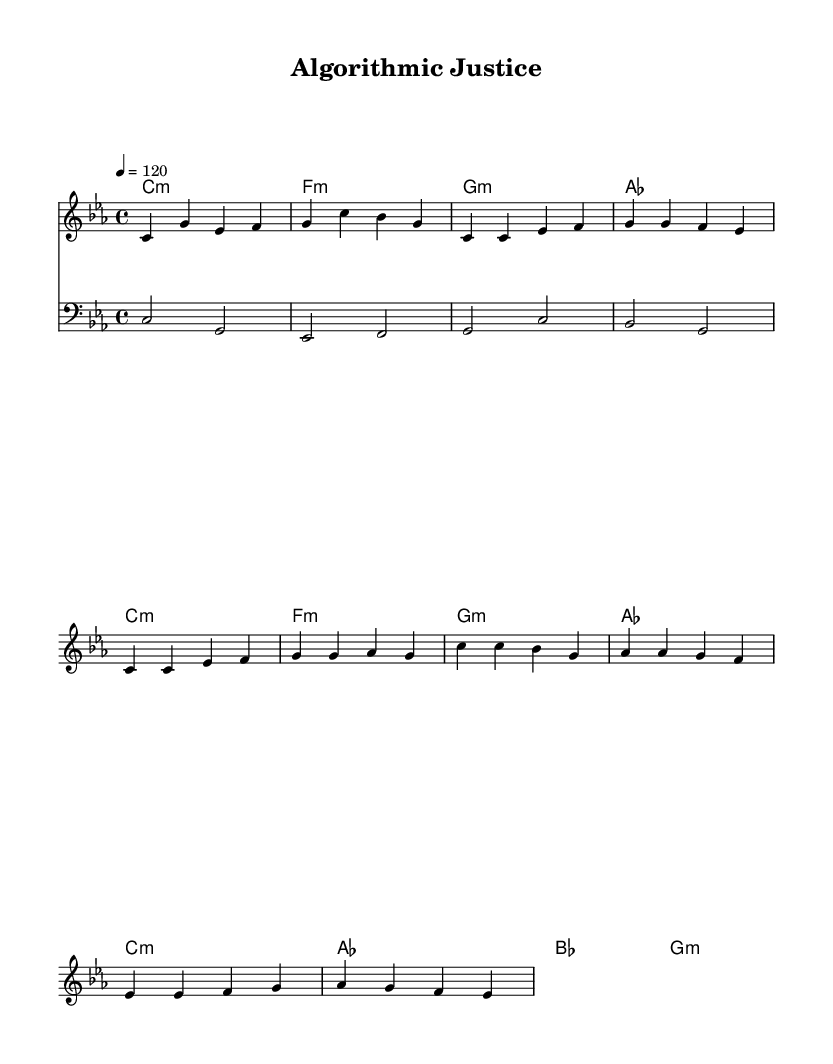What is the key signature of this music? The key signature is C minor, which typically has three flats: B flat, E flat, and A flat. This is determined by observing the key indicated at the beginning of the score.
Answer: C minor What is the time signature of this music? The time signature is 4/4, which is shown at the beginning of the score, indicating that there are four beats per measure and the quarter note gets one beat.
Answer: 4/4 What is the tempo marking in this piece? The tempo marking in the piece indicates a speed of 120 beats per minute, specified by the number after the tempo indication. This is typically found near the beginning of the score.
Answer: 120 How many measures are in the chorus section? The chorus section contains four measures, which can be counted by looking at the notation of the chorus and identifying the first and last measures marked.
Answer: 4 What is the first note of the melody? The first note of the melody is C. This can be determined by looking at the very first note placed on the staff in the melody line.
Answer: C Which chord is played during the chorus? The chord played during the chorus is C minor. This can be identified by examining the chord names written above the melody line in the score corresponding to the measures of the chorus.
Answer: C minor What note is held in the bass line during the first measure? The note held in the bass line during the first measure is C. This is determined by checking the bass line notation under the chord as shown in the first measure of the bass staff.
Answer: C 